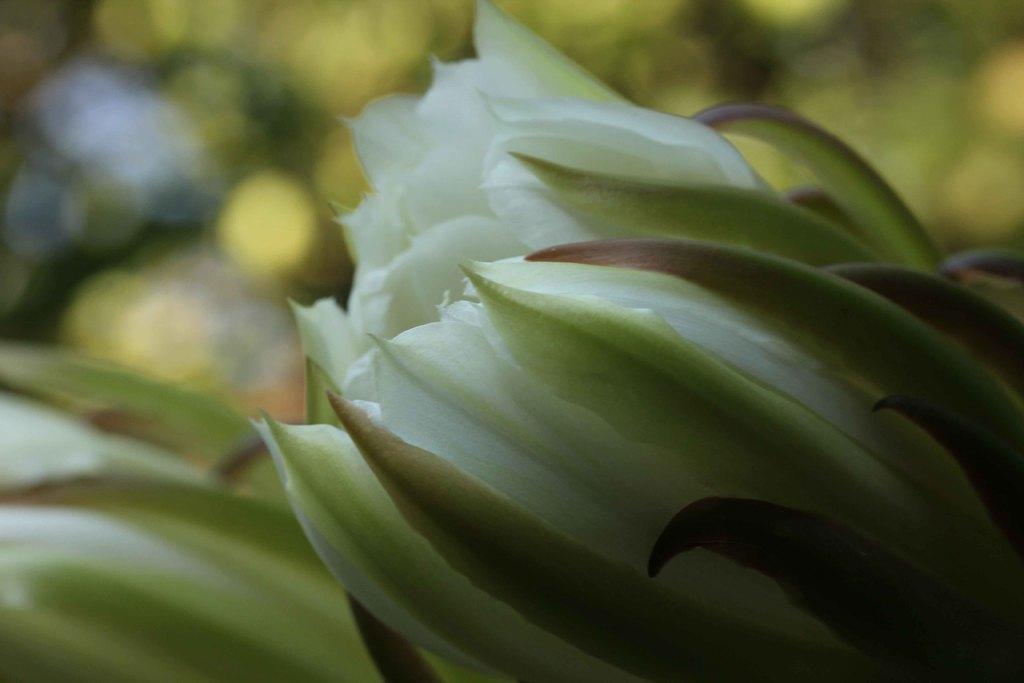How would you summarize this image in a sentence or two? As we can see in the image in the front there are white color flowers and the background is blurred. 